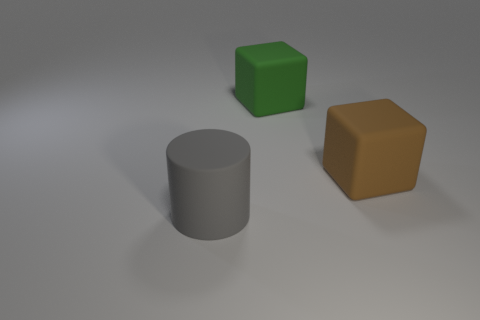Add 2 tiny blue metal balls. How many objects exist? 5 Subtract all cubes. How many objects are left? 1 Subtract all large green things. Subtract all green matte blocks. How many objects are left? 1 Add 3 large brown objects. How many large brown objects are left? 4 Add 2 large yellow matte spheres. How many large yellow matte spheres exist? 2 Subtract 0 red cubes. How many objects are left? 3 